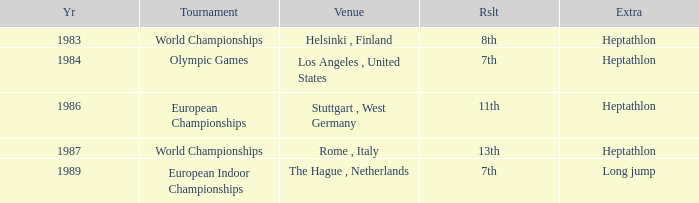How often are the Olympic games hosted? 1984.0. 